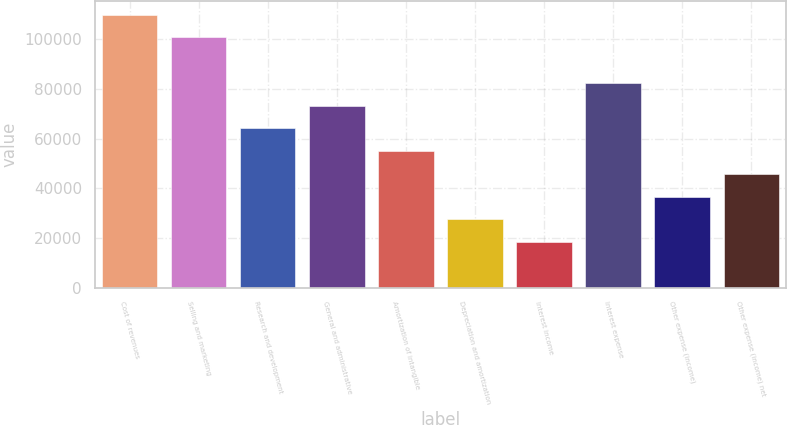Convert chart to OTSL. <chart><loc_0><loc_0><loc_500><loc_500><bar_chart><fcel>Cost of revenues<fcel>Selling and marketing<fcel>Research and development<fcel>General and administrative<fcel>Amortization of intangible<fcel>Depreciation and amortization<fcel>Interest income<fcel>Interest expense<fcel>Other expense (income)<fcel>Other expense (income) net<nl><fcel>109903<fcel>100744<fcel>64110.6<fcel>73269<fcel>54952.1<fcel>27476.7<fcel>18318.2<fcel>82427.5<fcel>36635.2<fcel>45793.6<nl></chart> 